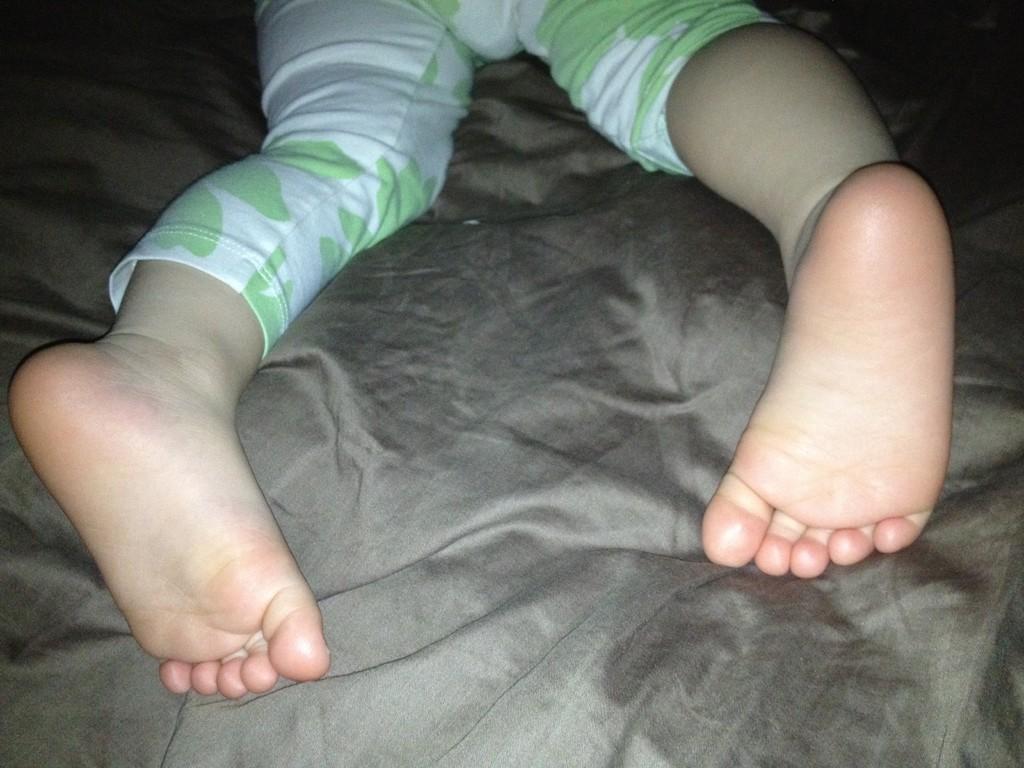How would you summarize this image in a sentence or two? In this image we can see a baby is lying on the bed, here is the bed sheet, here are the legs. 